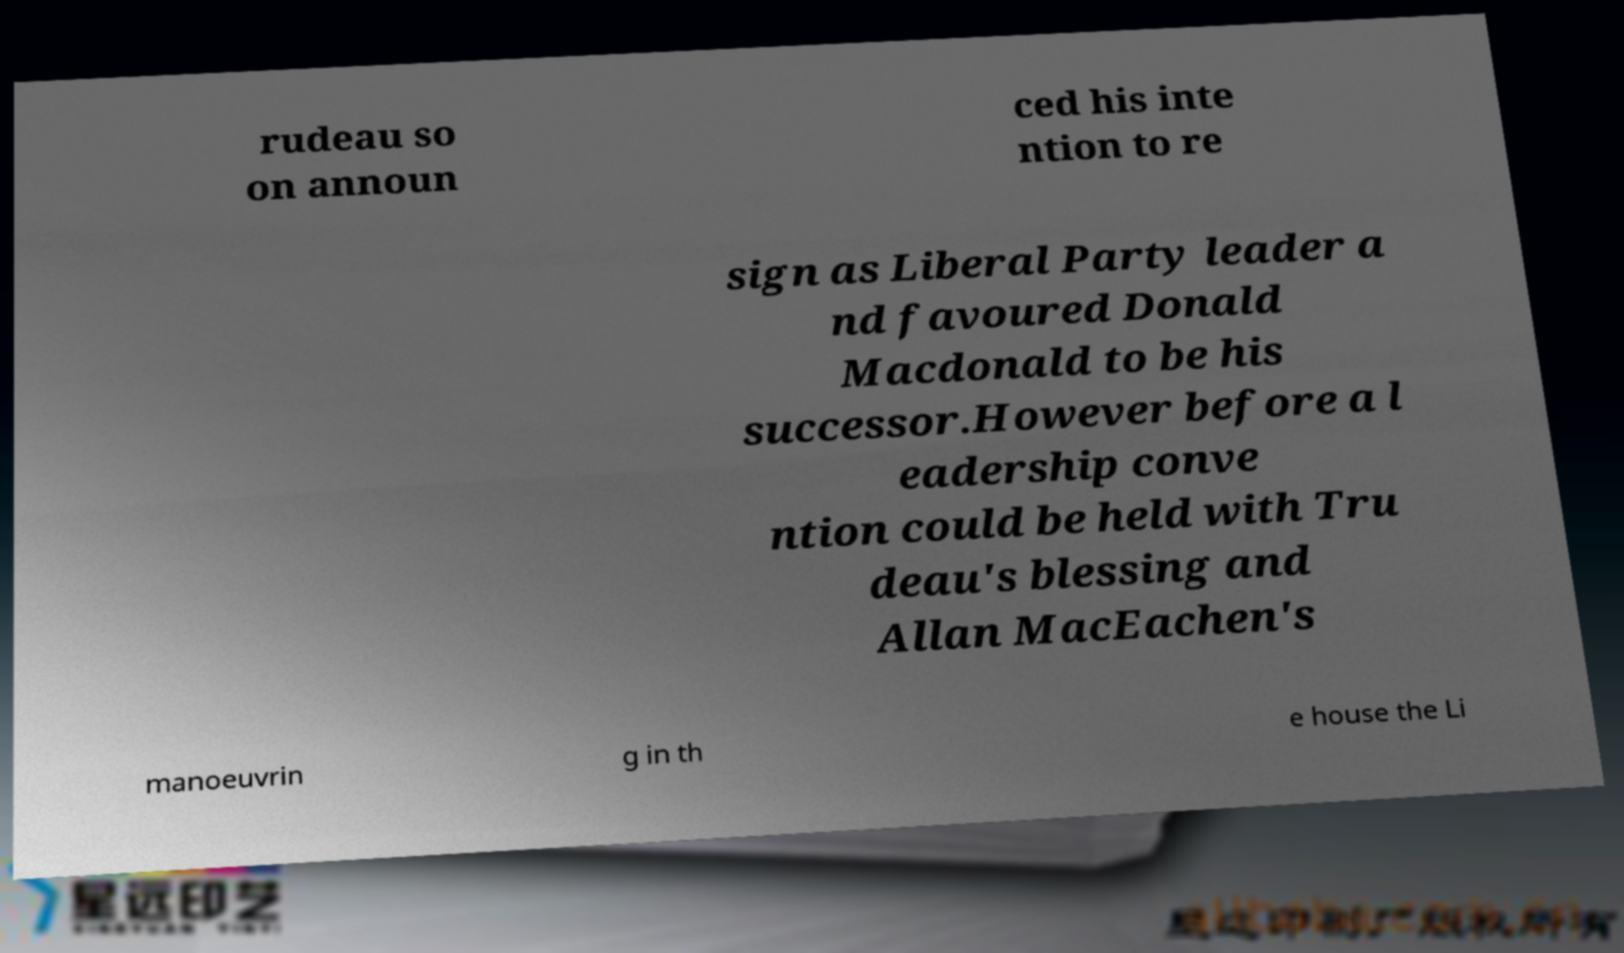Can you accurately transcribe the text from the provided image for me? rudeau so on announ ced his inte ntion to re sign as Liberal Party leader a nd favoured Donald Macdonald to be his successor.However before a l eadership conve ntion could be held with Tru deau's blessing and Allan MacEachen's manoeuvrin g in th e house the Li 